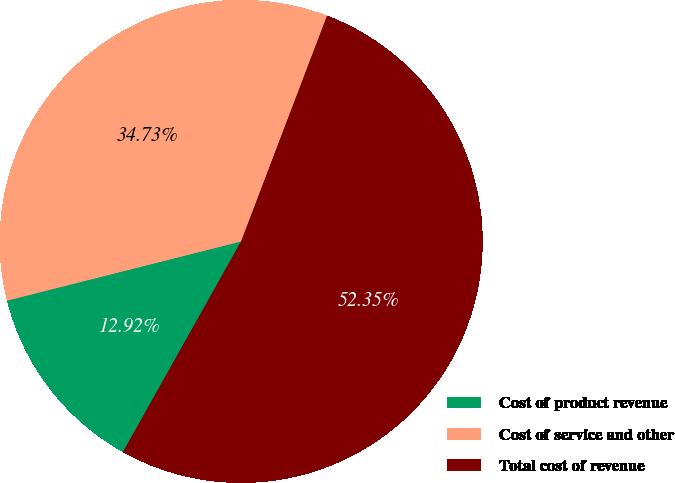Convert chart. <chart><loc_0><loc_0><loc_500><loc_500><pie_chart><fcel>Cost of product revenue<fcel>Cost of service and other<fcel>Total cost of revenue<nl><fcel>12.92%<fcel>34.73%<fcel>52.35%<nl></chart> 